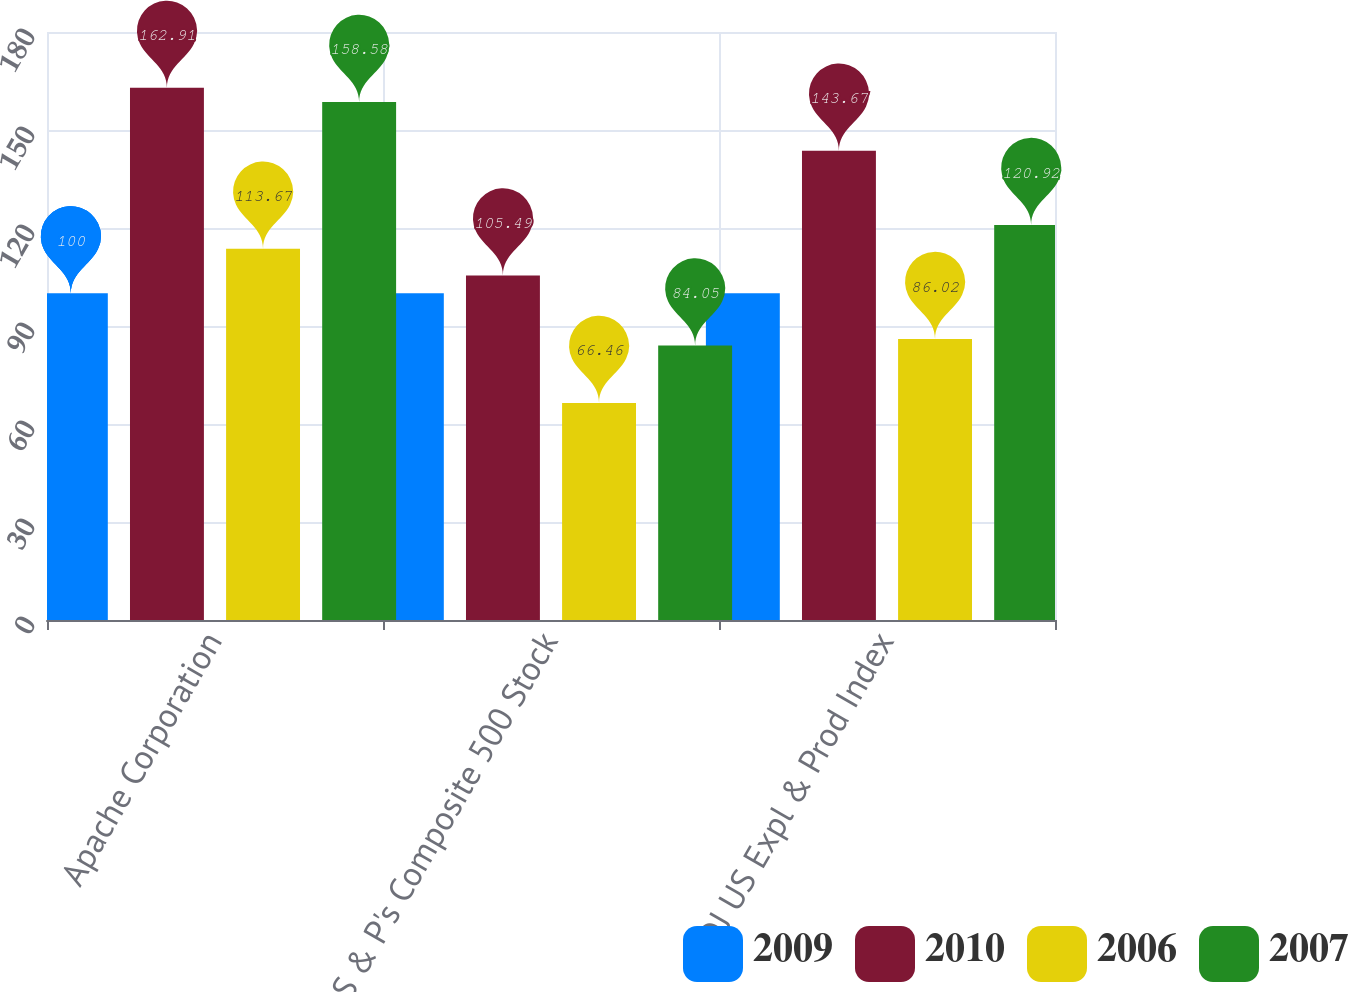Convert chart. <chart><loc_0><loc_0><loc_500><loc_500><stacked_bar_chart><ecel><fcel>Apache Corporation<fcel>S & P's Composite 500 Stock<fcel>DJ US Expl & Prod Index<nl><fcel>2009<fcel>100<fcel>100<fcel>100<nl><fcel>2010<fcel>162.91<fcel>105.49<fcel>143.67<nl><fcel>2006<fcel>113.67<fcel>66.46<fcel>86.02<nl><fcel>2007<fcel>158.58<fcel>84.05<fcel>120.92<nl></chart> 